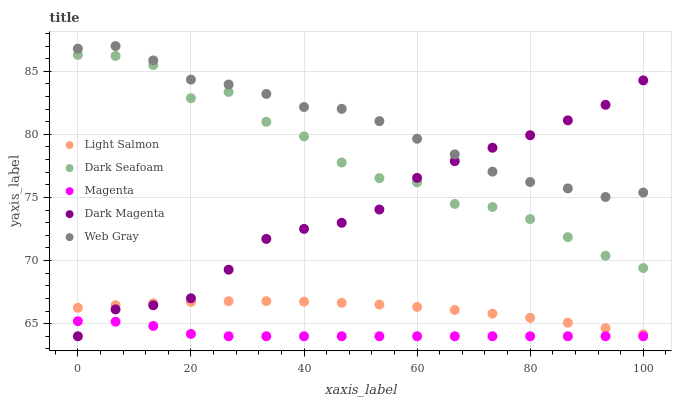Does Magenta have the minimum area under the curve?
Answer yes or no. Yes. Does Web Gray have the maximum area under the curve?
Answer yes or no. Yes. Does Dark Seafoam have the minimum area under the curve?
Answer yes or no. No. Does Dark Seafoam have the maximum area under the curve?
Answer yes or no. No. Is Light Salmon the smoothest?
Answer yes or no. Yes. Is Dark Seafoam the roughest?
Answer yes or no. Yes. Is Web Gray the smoothest?
Answer yes or no. No. Is Web Gray the roughest?
Answer yes or no. No. Does Magenta have the lowest value?
Answer yes or no. Yes. Does Dark Seafoam have the lowest value?
Answer yes or no. No. Does Web Gray have the highest value?
Answer yes or no. Yes. Does Dark Seafoam have the highest value?
Answer yes or no. No. Is Dark Seafoam less than Web Gray?
Answer yes or no. Yes. Is Web Gray greater than Light Salmon?
Answer yes or no. Yes. Does Dark Magenta intersect Dark Seafoam?
Answer yes or no. Yes. Is Dark Magenta less than Dark Seafoam?
Answer yes or no. No. Is Dark Magenta greater than Dark Seafoam?
Answer yes or no. No. Does Dark Seafoam intersect Web Gray?
Answer yes or no. No. 